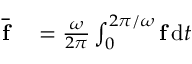Convert formula to latex. <formula><loc_0><loc_0><loc_500><loc_500>\begin{array} { r l } { \overline { f } } & = \frac { \omega } { 2 \pi } \int _ { 0 } ^ { 2 \pi / \omega } f \, d t } \end{array}</formula> 